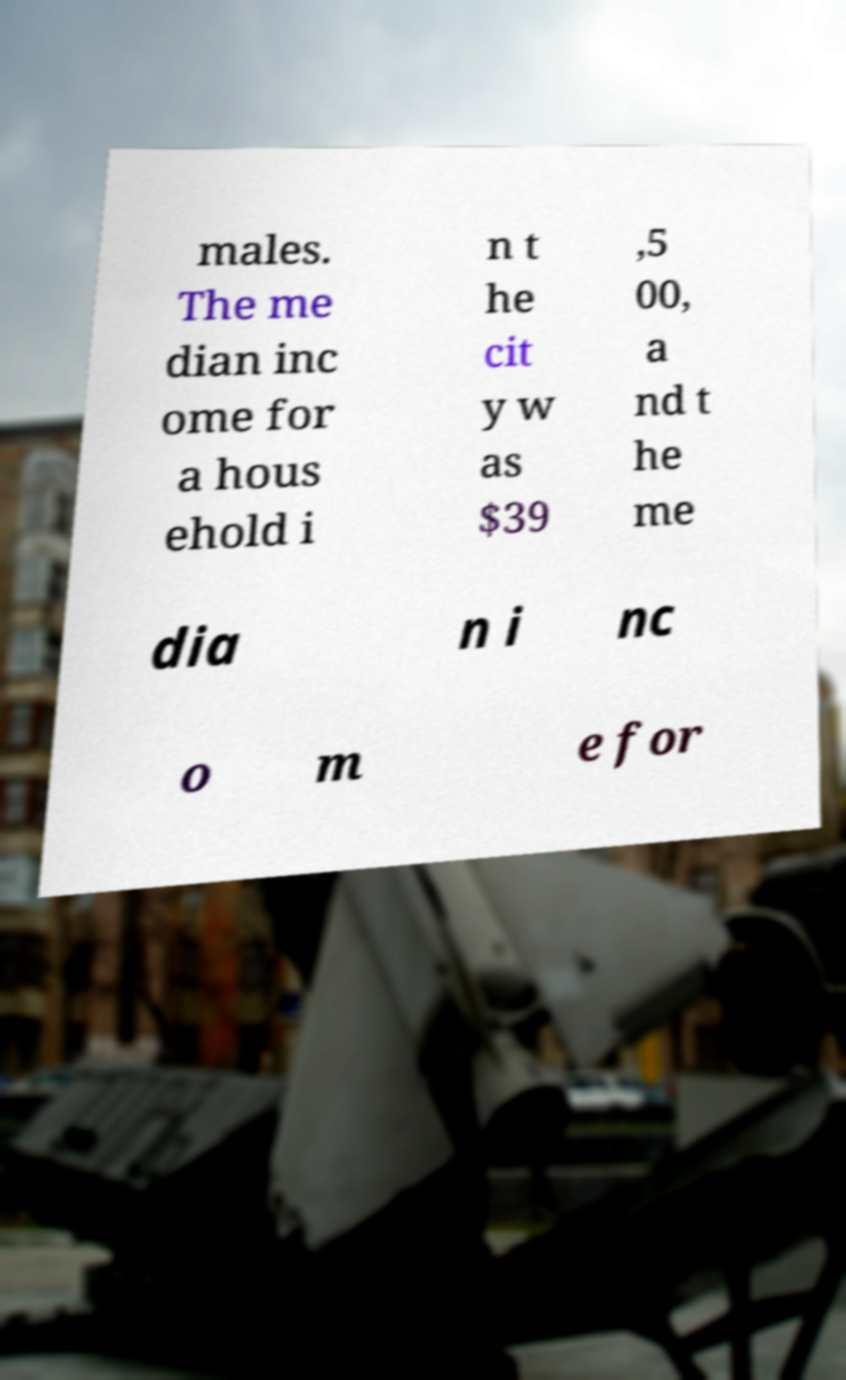Could you extract and type out the text from this image? males. The me dian inc ome for a hous ehold i n t he cit y w as $39 ,5 00, a nd t he me dia n i nc o m e for 